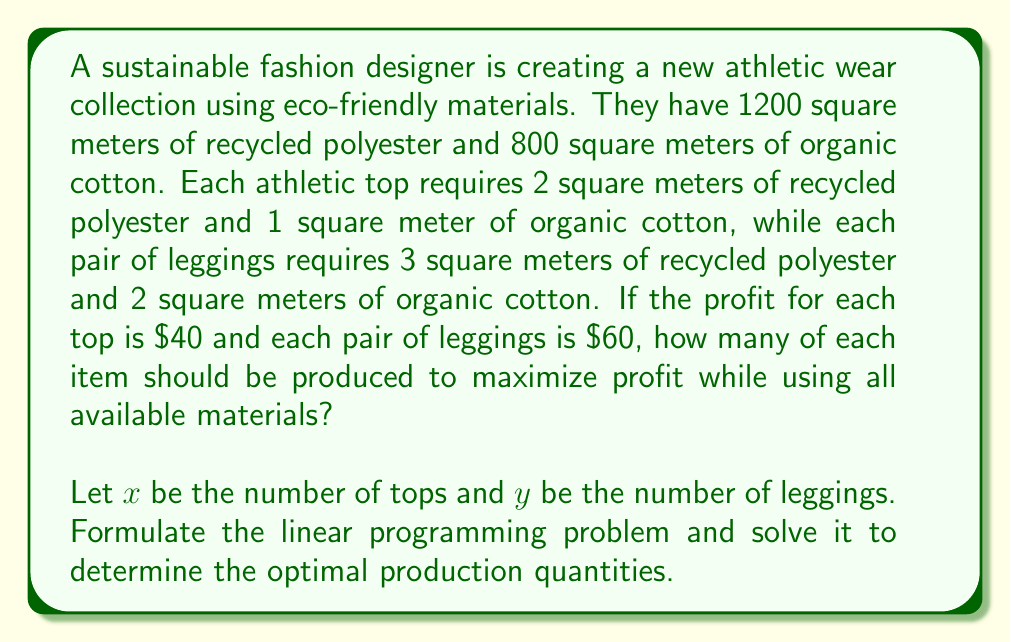Could you help me with this problem? To solve this problem, we need to set up a linear programming model and then solve it. Let's go through this step-by-step:

1. Define variables:
   $x$ = number of tops
   $y$ = number of leggings

2. Objective function (maximize profit):
   Maximize $Z = 40x + 60y$

3. Constraints:
   Recycled polyester: $2x + 3y \leq 1200$
   Organic cotton: $x + 2y \leq 800$
   Non-negativity: $x \geq 0, y \geq 0$

4. To solve this, we'll use the graphical method:

   a) Plot the constraints:
      For recycled polyester: $2x + 3y = 1200$
      x-intercept: (600, 0), y-intercept: (0, 400)
      
      For organic cotton: $x + 2y = 800$
      x-intercept: (800, 0), y-intercept: (0, 400)

   b) The feasible region is the area bounded by these lines and the non-negative axes.

   c) The optimal solution will be at one of the corner points of this region.

   d) Corner points:
      (0, 0), (600, 0), (400, 200), (0, 400)

   e) Evaluate the objective function at each point:
      (0, 0): Z = 0
      (600, 0): Z = 24,000
      (400, 200): Z = 28,000
      (0, 400): Z = 24,000

5. The maximum value occurs at (400, 200), which means producing 400 tops and 200 leggings.

6. Verify that this solution uses all materials:
   Recycled polyester: 2(400) + 3(200) = 1200 m²
   Organic cotton: 400 + 2(200) = 800 m²

Therefore, the optimal solution is to produce 400 tops and 200 leggings, which will maximize profit at $28,000 while using all available materials.
Answer: The optimal production quantities are 400 tops and 200 leggings, resulting in a maximum profit of $28,000. 